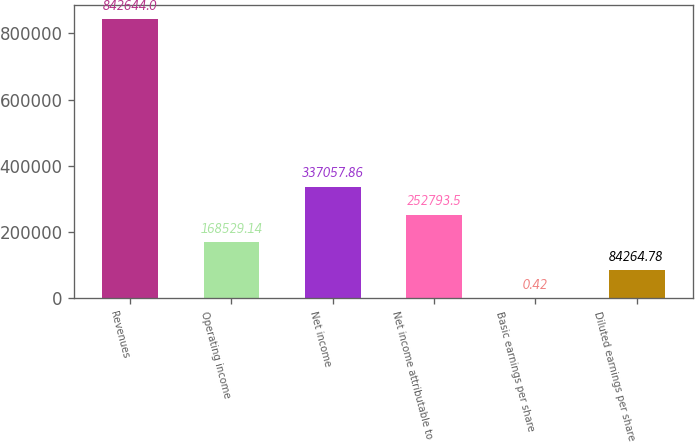<chart> <loc_0><loc_0><loc_500><loc_500><bar_chart><fcel>Revenues<fcel>Operating income<fcel>Net income<fcel>Net income attributable to<fcel>Basic earnings per share<fcel>Diluted earnings per share<nl><fcel>842644<fcel>168529<fcel>337058<fcel>252794<fcel>0.42<fcel>84264.8<nl></chart> 